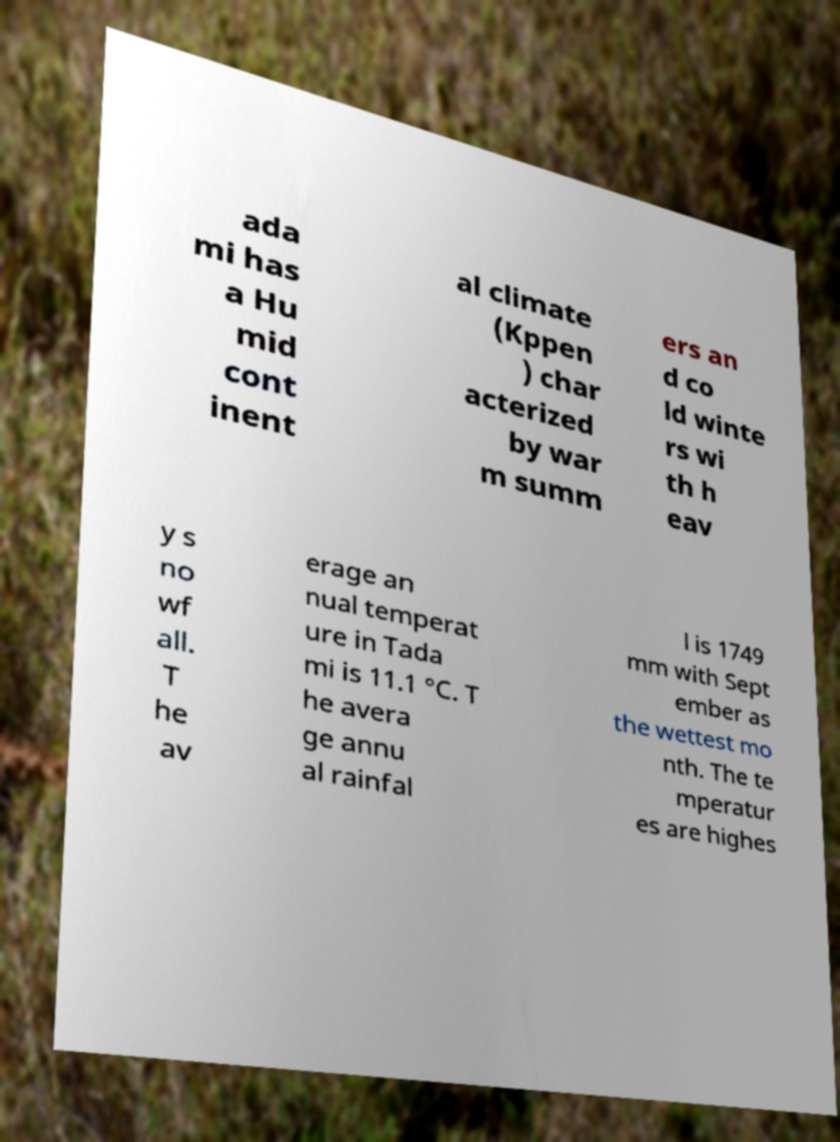Could you extract and type out the text from this image? ada mi has a Hu mid cont inent al climate (Kppen ) char acterized by war m summ ers an d co ld winte rs wi th h eav y s no wf all. T he av erage an nual temperat ure in Tada mi is 11.1 °C. T he avera ge annu al rainfal l is 1749 mm with Sept ember as the wettest mo nth. The te mperatur es are highes 